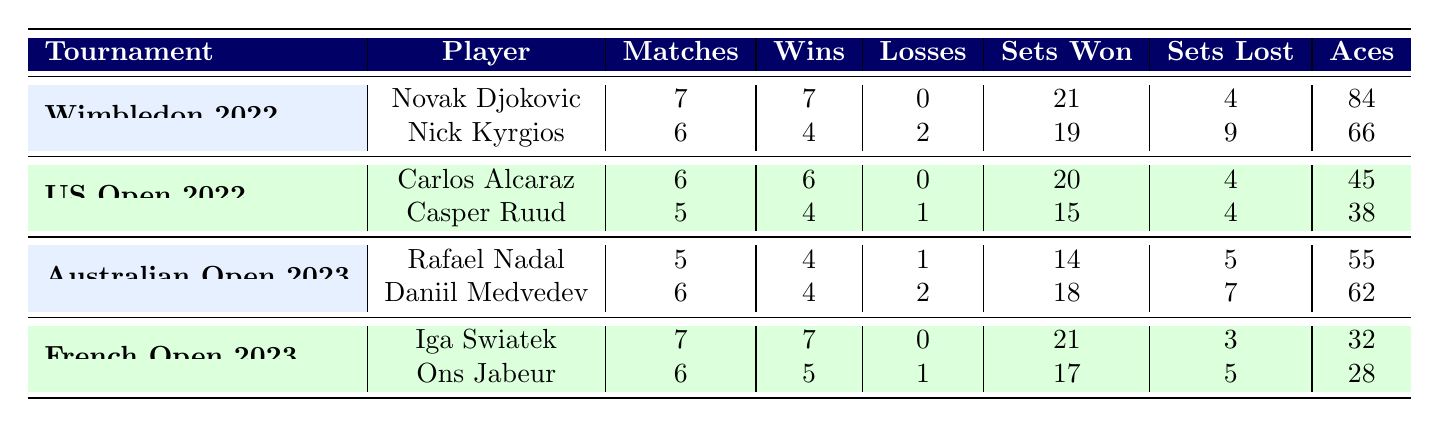What player had the highest number of aces in Wimbledon 2022? In Wimbledon 2022, Novak Djokovic had 84 aces while Nick Kyrgios had 66 aces. Therefore, Novak Djokovic had the highest number of aces during that tournament.
Answer: Novak Djokovic Did Carlos Alcaraz lose any matches in the US Open 2022? According to the table, Carlos Alcaraz played 6 matches and won all of them, which indicates that he had no losses in the tournament.
Answer: No What is the total number of matches played by players in the Australian Open 2023? Rafael Nadal played 5 matches and Daniil Medvedev played 6 matches. Adding these together, 5 + 6 equals a total of 11 matches played by all players.
Answer: 11 Which player had the most sets won in the French Open 2023? Iga Swiatek won 21 sets while Ons Jabeur won 17 sets. Comparing these figures, Iga Swiatek had the most sets won during the tournament.
Answer: Iga Swiatek How many losses did players incur in the US Open 2022 combined? Carlos Alcaraz had 0 losses and Casper Ruud had 1 loss. Adding these gives a total of 0 + 1, resulting in 1 combined loss in the US Open 2022.
Answer: 1 Was Iga Swiatek undefeated in the French Open 2023? Iga Swiatek won all 7 matches played, which means she did not incur any losses, hence she was indeed undefeated in the tournament.
Answer: Yes What is the average number of sets lost by players in the Australian Open 2023? Rafael Nadal lost 5 sets and Daniil Medvedev lost 7 sets. The sum is 5 + 7 = 12 sets lost among 2 players. Dividing by 2 (the number of players) results in an average of 6 sets lost.
Answer: 6 Which tournament had the fewest total sets lost by its players? Analyzing the sets lost: Wimbledon 2022 had 13, US Open 2022 had 4, Australian Open 2023 had 12, and French Open 2023 had 8. The US Open 2022 had the fewest total sets lost combined with 4.
Answer: US Open 2022 How many players had zero losses across all the tournaments noted in the table? Looking at each tournament: Novak Djokovic and Iga Swiatek each had 0 losses in Wimbledon 2022 and French Open 2023 respectively, and Carlos Alcaraz had 0 losses in the US Open 2022. This totals 3 players with zero losses.
Answer: 3 